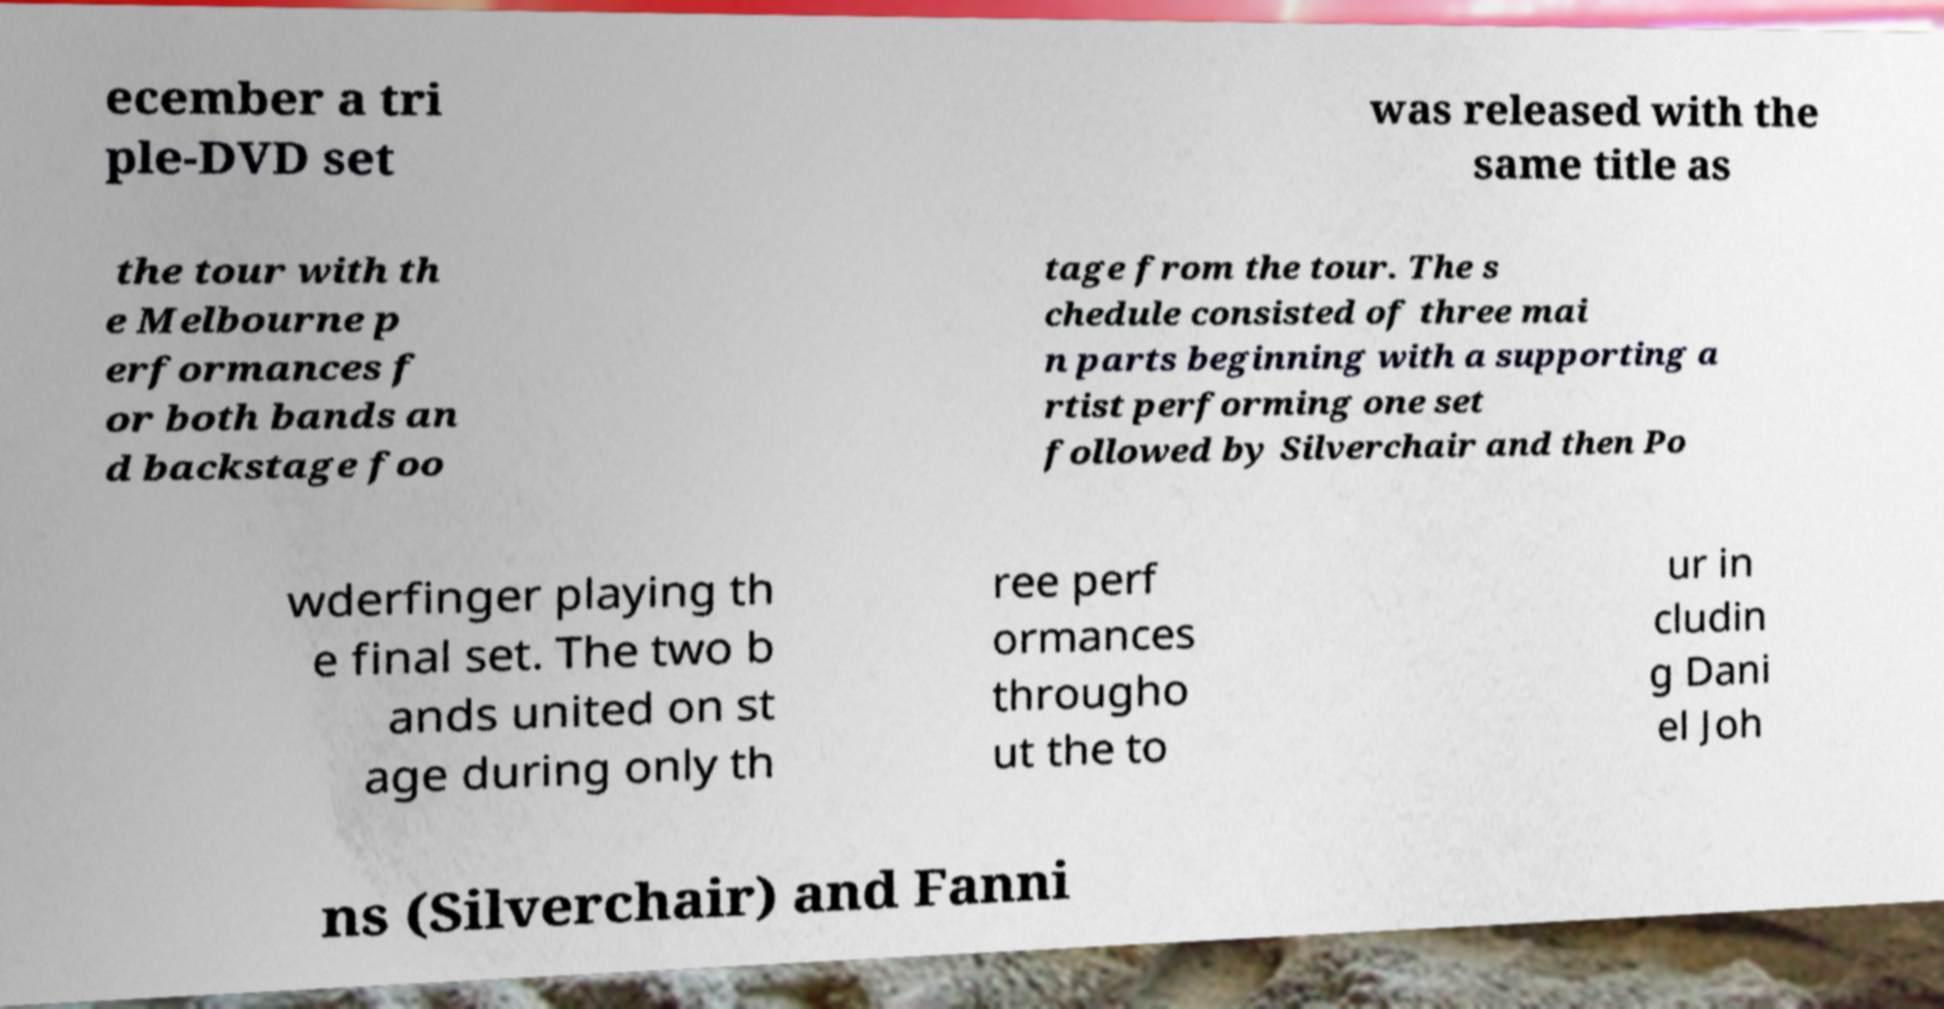Can you read and provide the text displayed in the image?This photo seems to have some interesting text. Can you extract and type it out for me? ecember a tri ple-DVD set was released with the same title as the tour with th e Melbourne p erformances f or both bands an d backstage foo tage from the tour. The s chedule consisted of three mai n parts beginning with a supporting a rtist performing one set followed by Silverchair and then Po wderfinger playing th e final set. The two b ands united on st age during only th ree perf ormances througho ut the to ur in cludin g Dani el Joh ns (Silverchair) and Fanni 